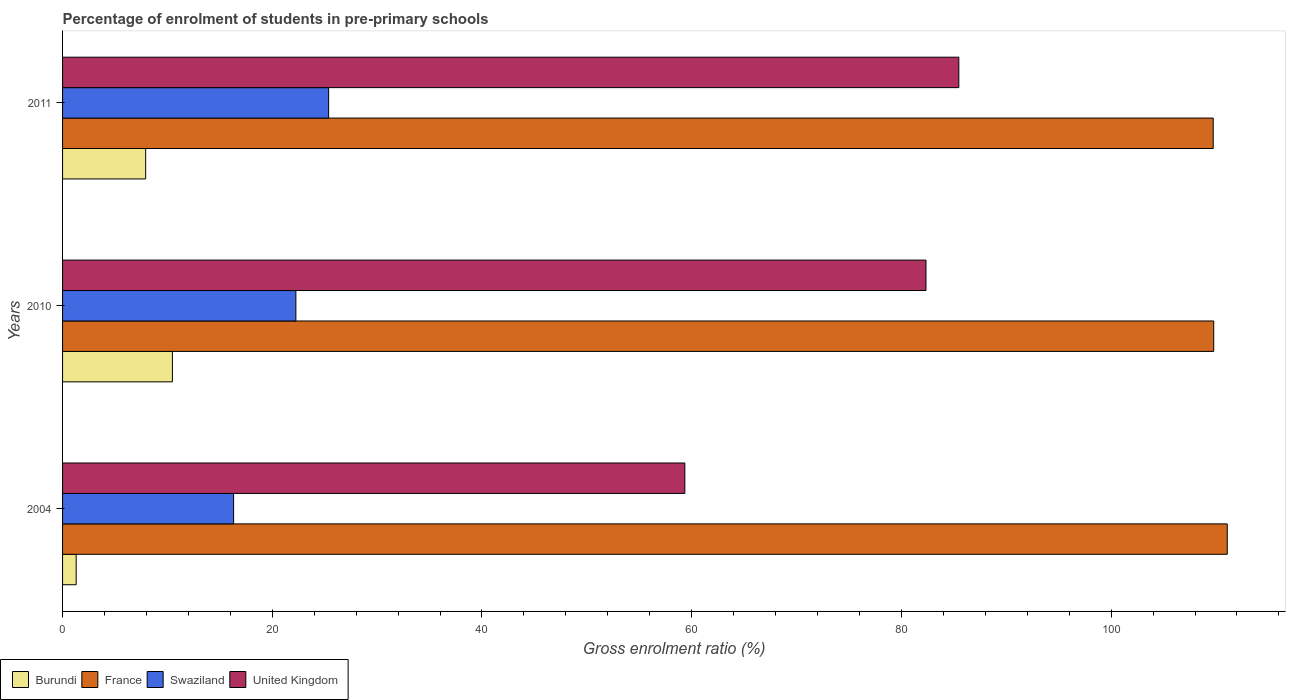Are the number of bars per tick equal to the number of legend labels?
Give a very brief answer. Yes. Are the number of bars on each tick of the Y-axis equal?
Offer a terse response. Yes. How many bars are there on the 3rd tick from the top?
Your answer should be compact. 4. What is the percentage of students enrolled in pre-primary schools in Burundi in 2010?
Provide a short and direct response. 10.48. Across all years, what is the maximum percentage of students enrolled in pre-primary schools in Burundi?
Provide a succinct answer. 10.48. Across all years, what is the minimum percentage of students enrolled in pre-primary schools in France?
Your answer should be compact. 109.74. In which year was the percentage of students enrolled in pre-primary schools in France minimum?
Provide a short and direct response. 2011. What is the total percentage of students enrolled in pre-primary schools in United Kingdom in the graph?
Your answer should be very brief. 227.16. What is the difference between the percentage of students enrolled in pre-primary schools in France in 2004 and that in 2010?
Offer a terse response. 1.29. What is the difference between the percentage of students enrolled in pre-primary schools in France in 2004 and the percentage of students enrolled in pre-primary schools in Burundi in 2010?
Offer a very short reply. 100.6. What is the average percentage of students enrolled in pre-primary schools in Burundi per year?
Offer a terse response. 6.57. In the year 2004, what is the difference between the percentage of students enrolled in pre-primary schools in United Kingdom and percentage of students enrolled in pre-primary schools in Swaziland?
Ensure brevity in your answer.  43.03. What is the ratio of the percentage of students enrolled in pre-primary schools in Burundi in 2004 to that in 2010?
Provide a short and direct response. 0.12. Is the percentage of students enrolled in pre-primary schools in France in 2004 less than that in 2011?
Provide a succinct answer. No. What is the difference between the highest and the second highest percentage of students enrolled in pre-primary schools in Burundi?
Provide a short and direct response. 2.55. What is the difference between the highest and the lowest percentage of students enrolled in pre-primary schools in United Kingdom?
Provide a short and direct response. 26.13. In how many years, is the percentage of students enrolled in pre-primary schools in France greater than the average percentage of students enrolled in pre-primary schools in France taken over all years?
Ensure brevity in your answer.  1. Is it the case that in every year, the sum of the percentage of students enrolled in pre-primary schools in France and percentage of students enrolled in pre-primary schools in Swaziland is greater than the sum of percentage of students enrolled in pre-primary schools in Burundi and percentage of students enrolled in pre-primary schools in United Kingdom?
Your response must be concise. Yes. What does the 2nd bar from the top in 2004 represents?
Provide a succinct answer. Swaziland. What does the 3rd bar from the bottom in 2011 represents?
Offer a terse response. Swaziland. How many bars are there?
Provide a short and direct response. 12. Are all the bars in the graph horizontal?
Your answer should be compact. Yes. How many years are there in the graph?
Provide a succinct answer. 3. Are the values on the major ticks of X-axis written in scientific E-notation?
Your response must be concise. No. Does the graph contain any zero values?
Your answer should be very brief. No. How many legend labels are there?
Provide a succinct answer. 4. How are the legend labels stacked?
Your answer should be very brief. Horizontal. What is the title of the graph?
Your answer should be very brief. Percentage of enrolment of students in pre-primary schools. Does "Luxembourg" appear as one of the legend labels in the graph?
Give a very brief answer. No. What is the label or title of the X-axis?
Make the answer very short. Gross enrolment ratio (%). What is the label or title of the Y-axis?
Ensure brevity in your answer.  Years. What is the Gross enrolment ratio (%) of Burundi in 2004?
Offer a very short reply. 1.3. What is the Gross enrolment ratio (%) of France in 2004?
Ensure brevity in your answer.  111.08. What is the Gross enrolment ratio (%) in Swaziland in 2004?
Give a very brief answer. 16.31. What is the Gross enrolment ratio (%) of United Kingdom in 2004?
Your answer should be very brief. 59.34. What is the Gross enrolment ratio (%) of Burundi in 2010?
Ensure brevity in your answer.  10.48. What is the Gross enrolment ratio (%) in France in 2010?
Ensure brevity in your answer.  109.78. What is the Gross enrolment ratio (%) in Swaziland in 2010?
Your response must be concise. 22.25. What is the Gross enrolment ratio (%) in United Kingdom in 2010?
Give a very brief answer. 82.34. What is the Gross enrolment ratio (%) of Burundi in 2011?
Make the answer very short. 7.93. What is the Gross enrolment ratio (%) in France in 2011?
Offer a terse response. 109.74. What is the Gross enrolment ratio (%) of Swaziland in 2011?
Provide a succinct answer. 25.38. What is the Gross enrolment ratio (%) in United Kingdom in 2011?
Give a very brief answer. 85.47. Across all years, what is the maximum Gross enrolment ratio (%) of Burundi?
Provide a short and direct response. 10.48. Across all years, what is the maximum Gross enrolment ratio (%) in France?
Provide a short and direct response. 111.08. Across all years, what is the maximum Gross enrolment ratio (%) in Swaziland?
Offer a very short reply. 25.38. Across all years, what is the maximum Gross enrolment ratio (%) of United Kingdom?
Your answer should be very brief. 85.47. Across all years, what is the minimum Gross enrolment ratio (%) of Burundi?
Provide a succinct answer. 1.3. Across all years, what is the minimum Gross enrolment ratio (%) in France?
Your answer should be very brief. 109.74. Across all years, what is the minimum Gross enrolment ratio (%) of Swaziland?
Your answer should be very brief. 16.31. Across all years, what is the minimum Gross enrolment ratio (%) of United Kingdom?
Your response must be concise. 59.34. What is the total Gross enrolment ratio (%) of Burundi in the graph?
Provide a succinct answer. 19.7. What is the total Gross enrolment ratio (%) of France in the graph?
Give a very brief answer. 330.6. What is the total Gross enrolment ratio (%) of Swaziland in the graph?
Ensure brevity in your answer.  63.94. What is the total Gross enrolment ratio (%) of United Kingdom in the graph?
Ensure brevity in your answer.  227.16. What is the difference between the Gross enrolment ratio (%) in Burundi in 2004 and that in 2010?
Your answer should be very brief. -9.18. What is the difference between the Gross enrolment ratio (%) in France in 2004 and that in 2010?
Your answer should be compact. 1.29. What is the difference between the Gross enrolment ratio (%) in Swaziland in 2004 and that in 2010?
Provide a short and direct response. -5.94. What is the difference between the Gross enrolment ratio (%) in United Kingdom in 2004 and that in 2010?
Make the answer very short. -23. What is the difference between the Gross enrolment ratio (%) in Burundi in 2004 and that in 2011?
Make the answer very short. -6.63. What is the difference between the Gross enrolment ratio (%) of France in 2004 and that in 2011?
Offer a very short reply. 1.34. What is the difference between the Gross enrolment ratio (%) in Swaziland in 2004 and that in 2011?
Your response must be concise. -9.06. What is the difference between the Gross enrolment ratio (%) of United Kingdom in 2004 and that in 2011?
Give a very brief answer. -26.13. What is the difference between the Gross enrolment ratio (%) in Burundi in 2010 and that in 2011?
Ensure brevity in your answer.  2.55. What is the difference between the Gross enrolment ratio (%) of France in 2010 and that in 2011?
Make the answer very short. 0.05. What is the difference between the Gross enrolment ratio (%) of Swaziland in 2010 and that in 2011?
Provide a short and direct response. -3.12. What is the difference between the Gross enrolment ratio (%) in United Kingdom in 2010 and that in 2011?
Make the answer very short. -3.13. What is the difference between the Gross enrolment ratio (%) in Burundi in 2004 and the Gross enrolment ratio (%) in France in 2010?
Provide a short and direct response. -108.49. What is the difference between the Gross enrolment ratio (%) in Burundi in 2004 and the Gross enrolment ratio (%) in Swaziland in 2010?
Your answer should be compact. -20.95. What is the difference between the Gross enrolment ratio (%) in Burundi in 2004 and the Gross enrolment ratio (%) in United Kingdom in 2010?
Give a very brief answer. -81.05. What is the difference between the Gross enrolment ratio (%) of France in 2004 and the Gross enrolment ratio (%) of Swaziland in 2010?
Your response must be concise. 88.83. What is the difference between the Gross enrolment ratio (%) of France in 2004 and the Gross enrolment ratio (%) of United Kingdom in 2010?
Give a very brief answer. 28.73. What is the difference between the Gross enrolment ratio (%) of Swaziland in 2004 and the Gross enrolment ratio (%) of United Kingdom in 2010?
Your answer should be very brief. -66.03. What is the difference between the Gross enrolment ratio (%) in Burundi in 2004 and the Gross enrolment ratio (%) in France in 2011?
Provide a succinct answer. -108.44. What is the difference between the Gross enrolment ratio (%) of Burundi in 2004 and the Gross enrolment ratio (%) of Swaziland in 2011?
Provide a short and direct response. -24.08. What is the difference between the Gross enrolment ratio (%) of Burundi in 2004 and the Gross enrolment ratio (%) of United Kingdom in 2011?
Your answer should be very brief. -84.18. What is the difference between the Gross enrolment ratio (%) in France in 2004 and the Gross enrolment ratio (%) in Swaziland in 2011?
Ensure brevity in your answer.  85.7. What is the difference between the Gross enrolment ratio (%) of France in 2004 and the Gross enrolment ratio (%) of United Kingdom in 2011?
Keep it short and to the point. 25.6. What is the difference between the Gross enrolment ratio (%) of Swaziland in 2004 and the Gross enrolment ratio (%) of United Kingdom in 2011?
Provide a succinct answer. -69.16. What is the difference between the Gross enrolment ratio (%) of Burundi in 2010 and the Gross enrolment ratio (%) of France in 2011?
Offer a very short reply. -99.26. What is the difference between the Gross enrolment ratio (%) of Burundi in 2010 and the Gross enrolment ratio (%) of Swaziland in 2011?
Keep it short and to the point. -14.9. What is the difference between the Gross enrolment ratio (%) in Burundi in 2010 and the Gross enrolment ratio (%) in United Kingdom in 2011?
Your response must be concise. -75. What is the difference between the Gross enrolment ratio (%) of France in 2010 and the Gross enrolment ratio (%) of Swaziland in 2011?
Keep it short and to the point. 84.41. What is the difference between the Gross enrolment ratio (%) in France in 2010 and the Gross enrolment ratio (%) in United Kingdom in 2011?
Your response must be concise. 24.31. What is the difference between the Gross enrolment ratio (%) in Swaziland in 2010 and the Gross enrolment ratio (%) in United Kingdom in 2011?
Offer a very short reply. -63.22. What is the average Gross enrolment ratio (%) of Burundi per year?
Your answer should be compact. 6.57. What is the average Gross enrolment ratio (%) in France per year?
Keep it short and to the point. 110.2. What is the average Gross enrolment ratio (%) of Swaziland per year?
Keep it short and to the point. 21.31. What is the average Gross enrolment ratio (%) of United Kingdom per year?
Your answer should be very brief. 75.72. In the year 2004, what is the difference between the Gross enrolment ratio (%) in Burundi and Gross enrolment ratio (%) in France?
Your response must be concise. -109.78. In the year 2004, what is the difference between the Gross enrolment ratio (%) of Burundi and Gross enrolment ratio (%) of Swaziland?
Provide a short and direct response. -15.01. In the year 2004, what is the difference between the Gross enrolment ratio (%) of Burundi and Gross enrolment ratio (%) of United Kingdom?
Your answer should be very brief. -58.05. In the year 2004, what is the difference between the Gross enrolment ratio (%) in France and Gross enrolment ratio (%) in Swaziland?
Offer a terse response. 94.77. In the year 2004, what is the difference between the Gross enrolment ratio (%) in France and Gross enrolment ratio (%) in United Kingdom?
Give a very brief answer. 51.73. In the year 2004, what is the difference between the Gross enrolment ratio (%) in Swaziland and Gross enrolment ratio (%) in United Kingdom?
Your response must be concise. -43.03. In the year 2010, what is the difference between the Gross enrolment ratio (%) of Burundi and Gross enrolment ratio (%) of France?
Make the answer very short. -99.31. In the year 2010, what is the difference between the Gross enrolment ratio (%) of Burundi and Gross enrolment ratio (%) of Swaziland?
Ensure brevity in your answer.  -11.77. In the year 2010, what is the difference between the Gross enrolment ratio (%) in Burundi and Gross enrolment ratio (%) in United Kingdom?
Offer a very short reply. -71.87. In the year 2010, what is the difference between the Gross enrolment ratio (%) in France and Gross enrolment ratio (%) in Swaziland?
Make the answer very short. 87.53. In the year 2010, what is the difference between the Gross enrolment ratio (%) in France and Gross enrolment ratio (%) in United Kingdom?
Provide a short and direct response. 27.44. In the year 2010, what is the difference between the Gross enrolment ratio (%) of Swaziland and Gross enrolment ratio (%) of United Kingdom?
Ensure brevity in your answer.  -60.09. In the year 2011, what is the difference between the Gross enrolment ratio (%) of Burundi and Gross enrolment ratio (%) of France?
Provide a short and direct response. -101.81. In the year 2011, what is the difference between the Gross enrolment ratio (%) of Burundi and Gross enrolment ratio (%) of Swaziland?
Make the answer very short. -17.45. In the year 2011, what is the difference between the Gross enrolment ratio (%) in Burundi and Gross enrolment ratio (%) in United Kingdom?
Offer a terse response. -77.55. In the year 2011, what is the difference between the Gross enrolment ratio (%) in France and Gross enrolment ratio (%) in Swaziland?
Make the answer very short. 84.36. In the year 2011, what is the difference between the Gross enrolment ratio (%) of France and Gross enrolment ratio (%) of United Kingdom?
Give a very brief answer. 24.26. In the year 2011, what is the difference between the Gross enrolment ratio (%) in Swaziland and Gross enrolment ratio (%) in United Kingdom?
Keep it short and to the point. -60.1. What is the ratio of the Gross enrolment ratio (%) in Burundi in 2004 to that in 2010?
Provide a succinct answer. 0.12. What is the ratio of the Gross enrolment ratio (%) in France in 2004 to that in 2010?
Offer a very short reply. 1.01. What is the ratio of the Gross enrolment ratio (%) in Swaziland in 2004 to that in 2010?
Your answer should be compact. 0.73. What is the ratio of the Gross enrolment ratio (%) of United Kingdom in 2004 to that in 2010?
Provide a succinct answer. 0.72. What is the ratio of the Gross enrolment ratio (%) of Burundi in 2004 to that in 2011?
Your answer should be compact. 0.16. What is the ratio of the Gross enrolment ratio (%) in France in 2004 to that in 2011?
Give a very brief answer. 1.01. What is the ratio of the Gross enrolment ratio (%) of Swaziland in 2004 to that in 2011?
Ensure brevity in your answer.  0.64. What is the ratio of the Gross enrolment ratio (%) of United Kingdom in 2004 to that in 2011?
Provide a short and direct response. 0.69. What is the ratio of the Gross enrolment ratio (%) in Burundi in 2010 to that in 2011?
Offer a very short reply. 1.32. What is the ratio of the Gross enrolment ratio (%) of France in 2010 to that in 2011?
Offer a terse response. 1. What is the ratio of the Gross enrolment ratio (%) in Swaziland in 2010 to that in 2011?
Keep it short and to the point. 0.88. What is the ratio of the Gross enrolment ratio (%) of United Kingdom in 2010 to that in 2011?
Provide a short and direct response. 0.96. What is the difference between the highest and the second highest Gross enrolment ratio (%) of Burundi?
Keep it short and to the point. 2.55. What is the difference between the highest and the second highest Gross enrolment ratio (%) of France?
Offer a very short reply. 1.29. What is the difference between the highest and the second highest Gross enrolment ratio (%) of Swaziland?
Offer a terse response. 3.12. What is the difference between the highest and the second highest Gross enrolment ratio (%) of United Kingdom?
Provide a short and direct response. 3.13. What is the difference between the highest and the lowest Gross enrolment ratio (%) in Burundi?
Your answer should be very brief. 9.18. What is the difference between the highest and the lowest Gross enrolment ratio (%) of France?
Keep it short and to the point. 1.34. What is the difference between the highest and the lowest Gross enrolment ratio (%) in Swaziland?
Keep it short and to the point. 9.06. What is the difference between the highest and the lowest Gross enrolment ratio (%) of United Kingdom?
Your response must be concise. 26.13. 